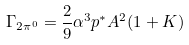<formula> <loc_0><loc_0><loc_500><loc_500>\Gamma _ { 2 \pi ^ { 0 } } = \frac { 2 } { 9 } \alpha ^ { 3 } p ^ { * } A ^ { 2 } ( 1 + K )</formula> 